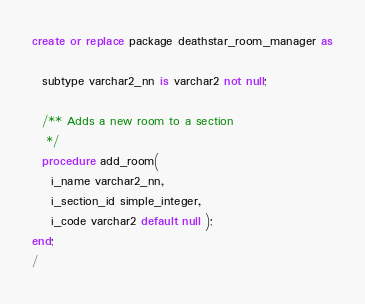Convert code to text. <code><loc_0><loc_0><loc_500><loc_500><_SQL_>create or replace package deathstar_room_manager as

  subtype varchar2_nn is varchar2 not null;

  /** Adds a new room to a section
   */
  procedure add_room(
    i_name varchar2_nn,
    i_section_id simple_integer,
    i_code varchar2 default null );
end;
/</code> 